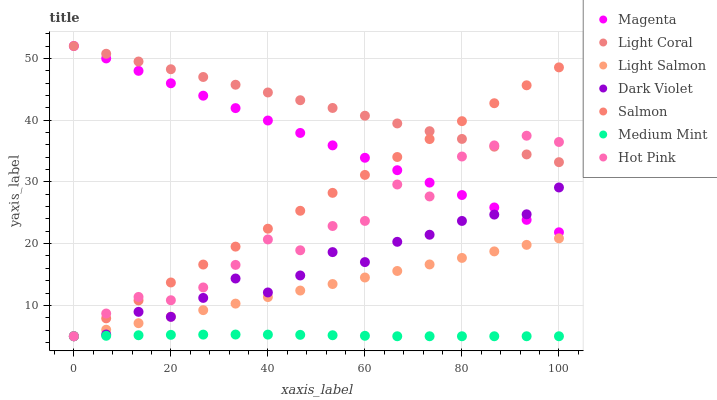Does Medium Mint have the minimum area under the curve?
Answer yes or no. Yes. Does Light Coral have the maximum area under the curve?
Answer yes or no. Yes. Does Light Salmon have the minimum area under the curve?
Answer yes or no. No. Does Light Salmon have the maximum area under the curve?
Answer yes or no. No. Is Light Salmon the smoothest?
Answer yes or no. Yes. Is Hot Pink the roughest?
Answer yes or no. Yes. Is Hot Pink the smoothest?
Answer yes or no. No. Is Light Salmon the roughest?
Answer yes or no. No. Does Medium Mint have the lowest value?
Answer yes or no. Yes. Does Light Coral have the lowest value?
Answer yes or no. No. Does Magenta have the highest value?
Answer yes or no. Yes. Does Light Salmon have the highest value?
Answer yes or no. No. Is Medium Mint less than Magenta?
Answer yes or no. Yes. Is Magenta greater than Light Salmon?
Answer yes or no. Yes. Does Hot Pink intersect Magenta?
Answer yes or no. Yes. Is Hot Pink less than Magenta?
Answer yes or no. No. Is Hot Pink greater than Magenta?
Answer yes or no. No. Does Medium Mint intersect Magenta?
Answer yes or no. No. 